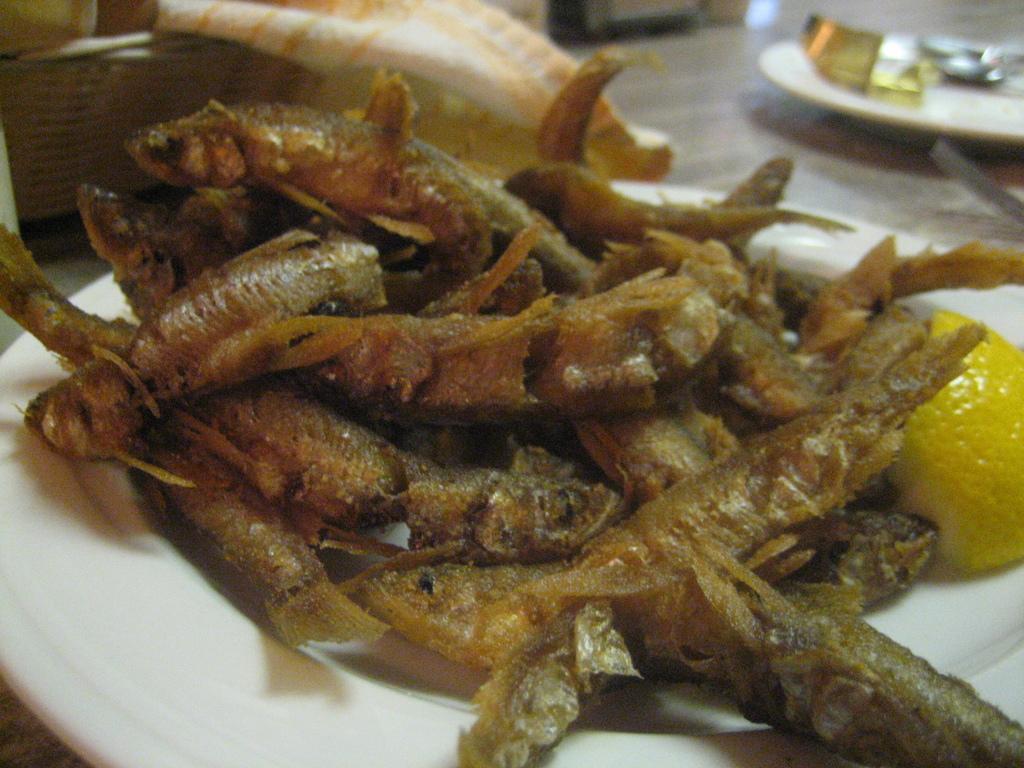In one or two sentences, can you explain what this image depicts? In this image there is a plate on which there is some food stuff. On the right side there is a lemon piece. In the background there is a basket in which there is a cloth. On the right side top there is a plate on which there are spoons. The plates are kept on the table. 